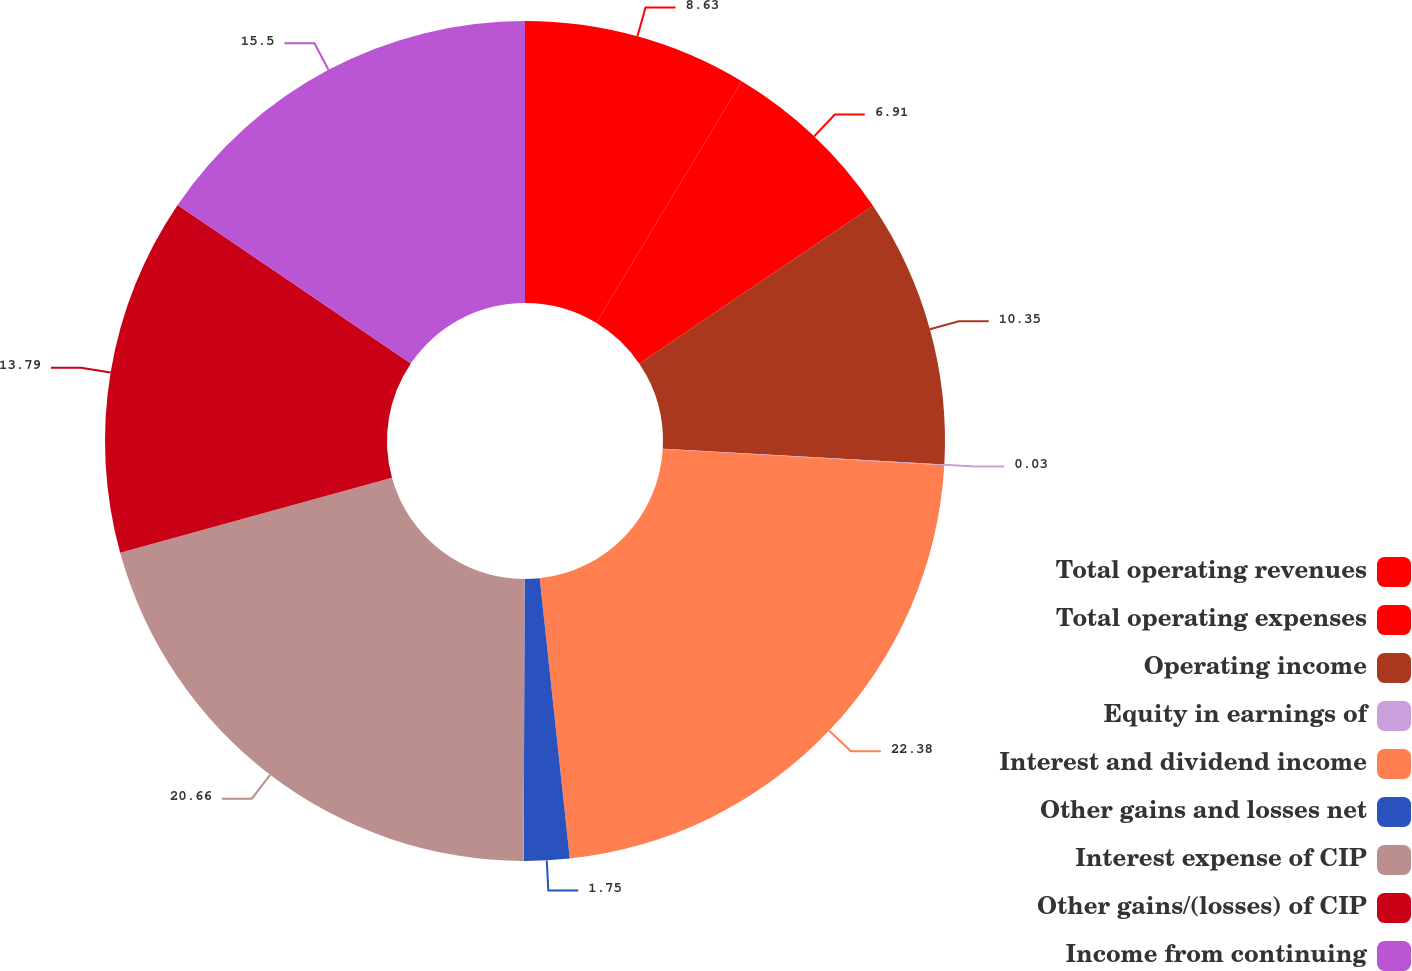<chart> <loc_0><loc_0><loc_500><loc_500><pie_chart><fcel>Total operating revenues<fcel>Total operating expenses<fcel>Operating income<fcel>Equity in earnings of<fcel>Interest and dividend income<fcel>Other gains and losses net<fcel>Interest expense of CIP<fcel>Other gains/(losses) of CIP<fcel>Income from continuing<nl><fcel>8.63%<fcel>6.91%<fcel>10.35%<fcel>0.03%<fcel>22.38%<fcel>1.75%<fcel>20.66%<fcel>13.79%<fcel>15.5%<nl></chart> 